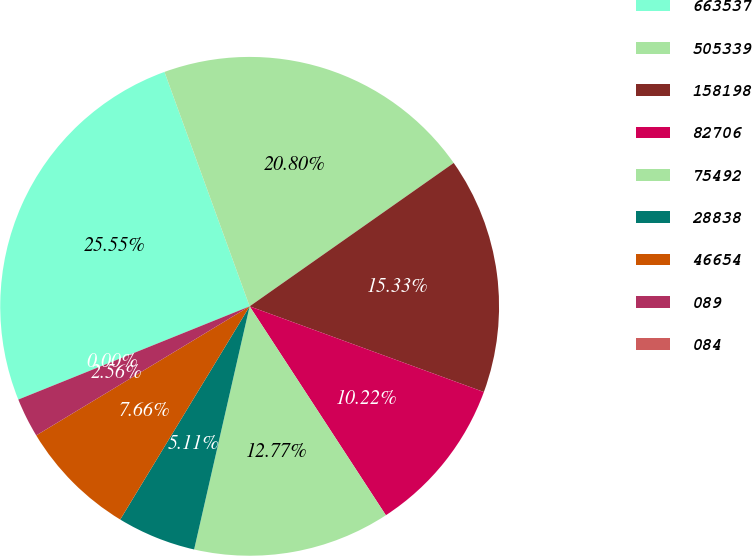Convert chart. <chart><loc_0><loc_0><loc_500><loc_500><pie_chart><fcel>663537<fcel>505339<fcel>158198<fcel>82706<fcel>75492<fcel>28838<fcel>46654<fcel>089<fcel>084<nl><fcel>25.55%<fcel>20.8%<fcel>15.33%<fcel>10.22%<fcel>12.77%<fcel>5.11%<fcel>7.66%<fcel>2.56%<fcel>0.0%<nl></chart> 